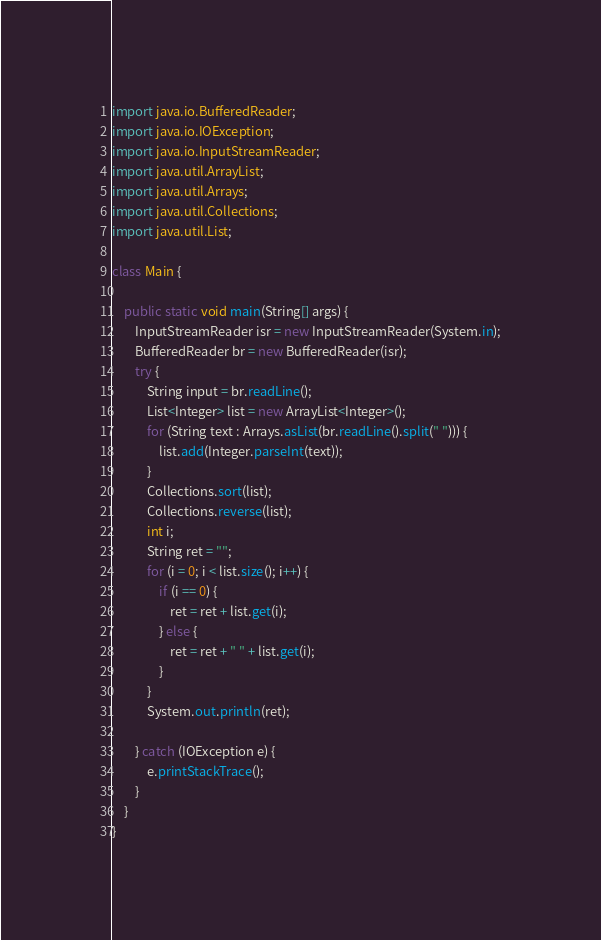Convert code to text. <code><loc_0><loc_0><loc_500><loc_500><_Java_>import java.io.BufferedReader;
import java.io.IOException;
import java.io.InputStreamReader;
import java.util.ArrayList;
import java.util.Arrays;
import java.util.Collections;
import java.util.List;

class Main {

	public static void main(String[] args) {
		InputStreamReader isr = new InputStreamReader(System.in);
		BufferedReader br = new BufferedReader(isr);
		try {
			String input = br.readLine();
			List<Integer> list = new ArrayList<Integer>();
			for (String text : Arrays.asList(br.readLine().split(" "))) {
				list.add(Integer.parseInt(text));
			}
			Collections.sort(list);
			Collections.reverse(list);
			int i;
			String ret = "";
			for (i = 0; i < list.size(); i++) {
				if (i == 0) {
					ret = ret + list.get(i);
				} else {
					ret = ret + " " + list.get(i);
				}
			}
			System.out.println(ret);

		} catch (IOException e) {
			e.printStackTrace();
		}
	}
}</code> 